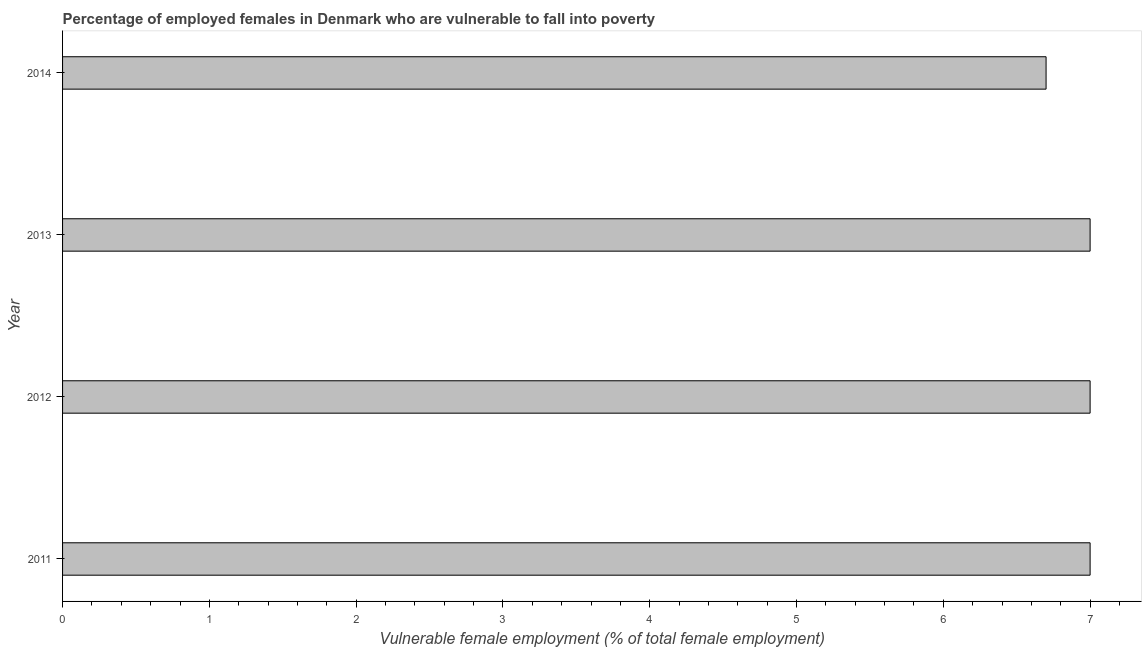Does the graph contain grids?
Provide a succinct answer. No. What is the title of the graph?
Make the answer very short. Percentage of employed females in Denmark who are vulnerable to fall into poverty. What is the label or title of the X-axis?
Your answer should be very brief. Vulnerable female employment (% of total female employment). What is the label or title of the Y-axis?
Your answer should be compact. Year. What is the percentage of employed females who are vulnerable to fall into poverty in 2011?
Make the answer very short. 7. Across all years, what is the minimum percentage of employed females who are vulnerable to fall into poverty?
Your response must be concise. 6.7. In which year was the percentage of employed females who are vulnerable to fall into poverty minimum?
Give a very brief answer. 2014. What is the sum of the percentage of employed females who are vulnerable to fall into poverty?
Offer a very short reply. 27.7. What is the difference between the percentage of employed females who are vulnerable to fall into poverty in 2011 and 2012?
Offer a very short reply. 0. What is the average percentage of employed females who are vulnerable to fall into poverty per year?
Provide a succinct answer. 6.92. What is the median percentage of employed females who are vulnerable to fall into poverty?
Provide a short and direct response. 7. In how many years, is the percentage of employed females who are vulnerable to fall into poverty greater than 1.4 %?
Your response must be concise. 4. Do a majority of the years between 2014 and 2013 (inclusive) have percentage of employed females who are vulnerable to fall into poverty greater than 6.4 %?
Offer a terse response. No. What is the difference between the highest and the second highest percentage of employed females who are vulnerable to fall into poverty?
Make the answer very short. 0. How many bars are there?
Keep it short and to the point. 4. Are all the bars in the graph horizontal?
Offer a very short reply. Yes. What is the difference between two consecutive major ticks on the X-axis?
Provide a short and direct response. 1. What is the Vulnerable female employment (% of total female employment) of 2011?
Offer a very short reply. 7. What is the Vulnerable female employment (% of total female employment) in 2012?
Make the answer very short. 7. What is the Vulnerable female employment (% of total female employment) of 2013?
Give a very brief answer. 7. What is the Vulnerable female employment (% of total female employment) of 2014?
Provide a short and direct response. 6.7. What is the difference between the Vulnerable female employment (% of total female employment) in 2012 and 2014?
Provide a short and direct response. 0.3. What is the difference between the Vulnerable female employment (% of total female employment) in 2013 and 2014?
Your answer should be compact. 0.3. What is the ratio of the Vulnerable female employment (% of total female employment) in 2011 to that in 2013?
Provide a short and direct response. 1. What is the ratio of the Vulnerable female employment (% of total female employment) in 2011 to that in 2014?
Offer a very short reply. 1.04. What is the ratio of the Vulnerable female employment (% of total female employment) in 2012 to that in 2014?
Offer a very short reply. 1.04. What is the ratio of the Vulnerable female employment (% of total female employment) in 2013 to that in 2014?
Your answer should be compact. 1.04. 